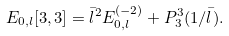Convert formula to latex. <formula><loc_0><loc_0><loc_500><loc_500>E _ { 0 , l } [ 3 , 3 ] = \bar { l } ^ { 2 } E _ { 0 , l } ^ { ( - 2 ) } + P _ { 3 } ^ { 3 } ( 1 / \bar { l } ) .</formula> 